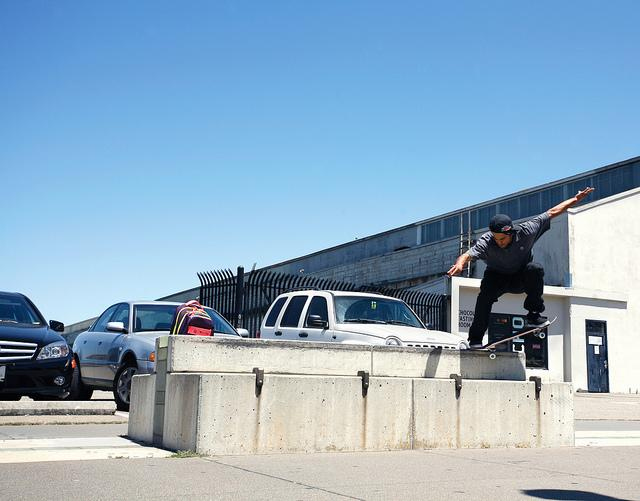What is the man on the board doing on the ledge? Please explain your reasoning. grinding. The other options don't fit his actions. 